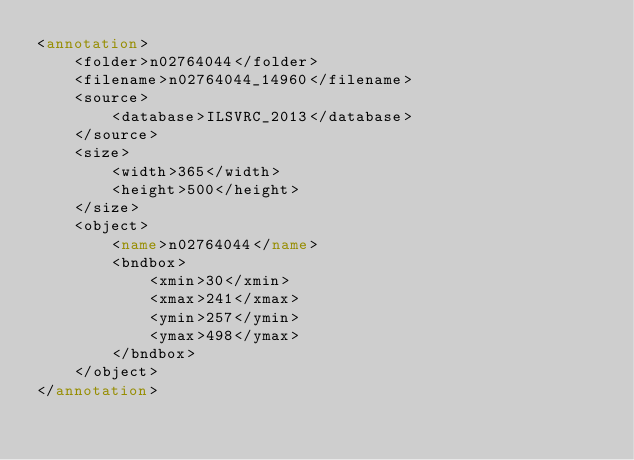<code> <loc_0><loc_0><loc_500><loc_500><_XML_><annotation>
	<folder>n02764044</folder>
	<filename>n02764044_14960</filename>
	<source>
		<database>ILSVRC_2013</database>
	</source>
	<size>
		<width>365</width>
		<height>500</height>
	</size>
	<object>
		<name>n02764044</name>
		<bndbox>
			<xmin>30</xmin>
			<xmax>241</xmax>
			<ymin>257</ymin>
			<ymax>498</ymax>
		</bndbox>
	</object>
</annotation>
</code> 